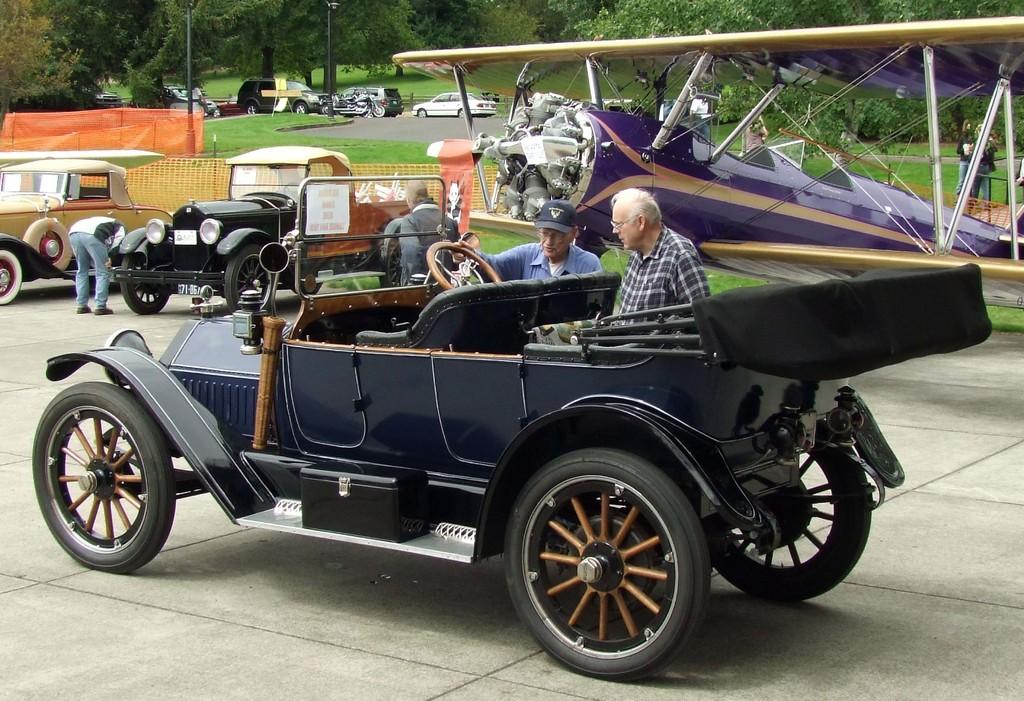What type of vehicles can be seen in the image? There are cars in the image. What are the people near the cars doing? People are standing beside the cars. What can be seen in the background of the image? There are trees in the background of the image. What type of surface is visible in the image? Grass is visible on the surface in the image. What type of argument is taking place between the cars in the image? There is no argument taking place between the cars in the image; they are stationary vehicles. 